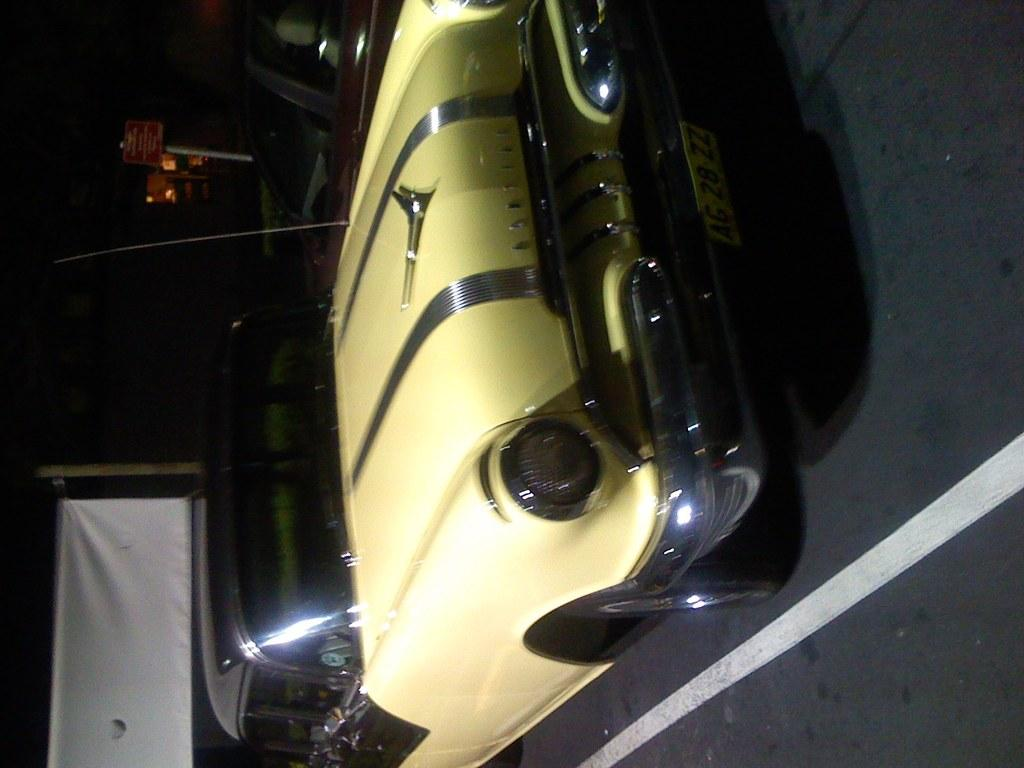What is the main subject of the image? There is a car on the road in the image. What can be seen in the background of the image? There is a banner and a board in the background of the image, along with other objects. How would you describe the lighting in the image? The image appears to be dark. What type of pail is being used to collect the smell in the image? There is no pail or smell present in the image. Can you tell me the account number of the car in the image? There is no account number associated with the car in the image. 